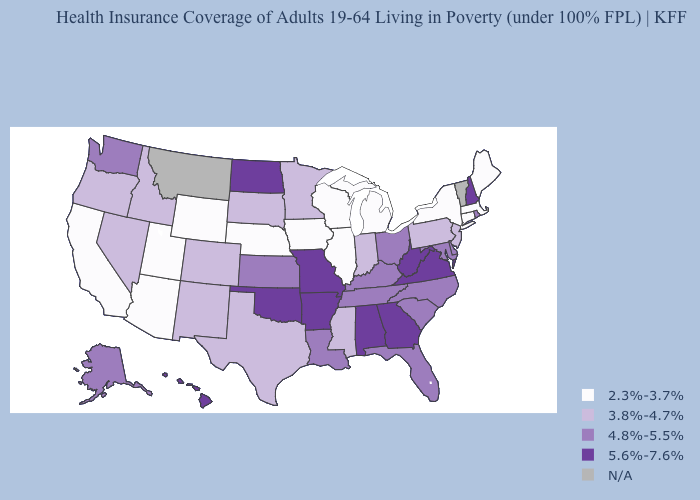What is the value of Wisconsin?
Concise answer only. 2.3%-3.7%. Does Hawaii have the highest value in the West?
Be succinct. Yes. What is the value of North Carolina?
Short answer required. 4.8%-5.5%. Among the states that border South Dakota , does Minnesota have the highest value?
Be succinct. No. What is the value of Utah?
Short answer required. 2.3%-3.7%. Name the states that have a value in the range 2.3%-3.7%?
Be succinct. Arizona, California, Connecticut, Illinois, Iowa, Maine, Massachusetts, Michigan, Nebraska, New York, Utah, Wisconsin, Wyoming. What is the value of Alaska?
Be succinct. 4.8%-5.5%. Which states have the highest value in the USA?
Answer briefly. Alabama, Arkansas, Georgia, Hawaii, Missouri, New Hampshire, North Dakota, Oklahoma, Virginia, West Virginia. What is the value of Georgia?
Write a very short answer. 5.6%-7.6%. Does New Mexico have the lowest value in the USA?
Write a very short answer. No. Which states hav the highest value in the West?
Concise answer only. Hawaii. Name the states that have a value in the range 3.8%-4.7%?
Be succinct. Colorado, Idaho, Indiana, Minnesota, Mississippi, Nevada, New Jersey, New Mexico, Oregon, Pennsylvania, South Dakota, Texas. Name the states that have a value in the range 4.8%-5.5%?
Be succinct. Alaska, Delaware, Florida, Kansas, Kentucky, Louisiana, Maryland, North Carolina, Ohio, Rhode Island, South Carolina, Tennessee, Washington. Among the states that border Illinois , does Missouri have the lowest value?
Short answer required. No. 